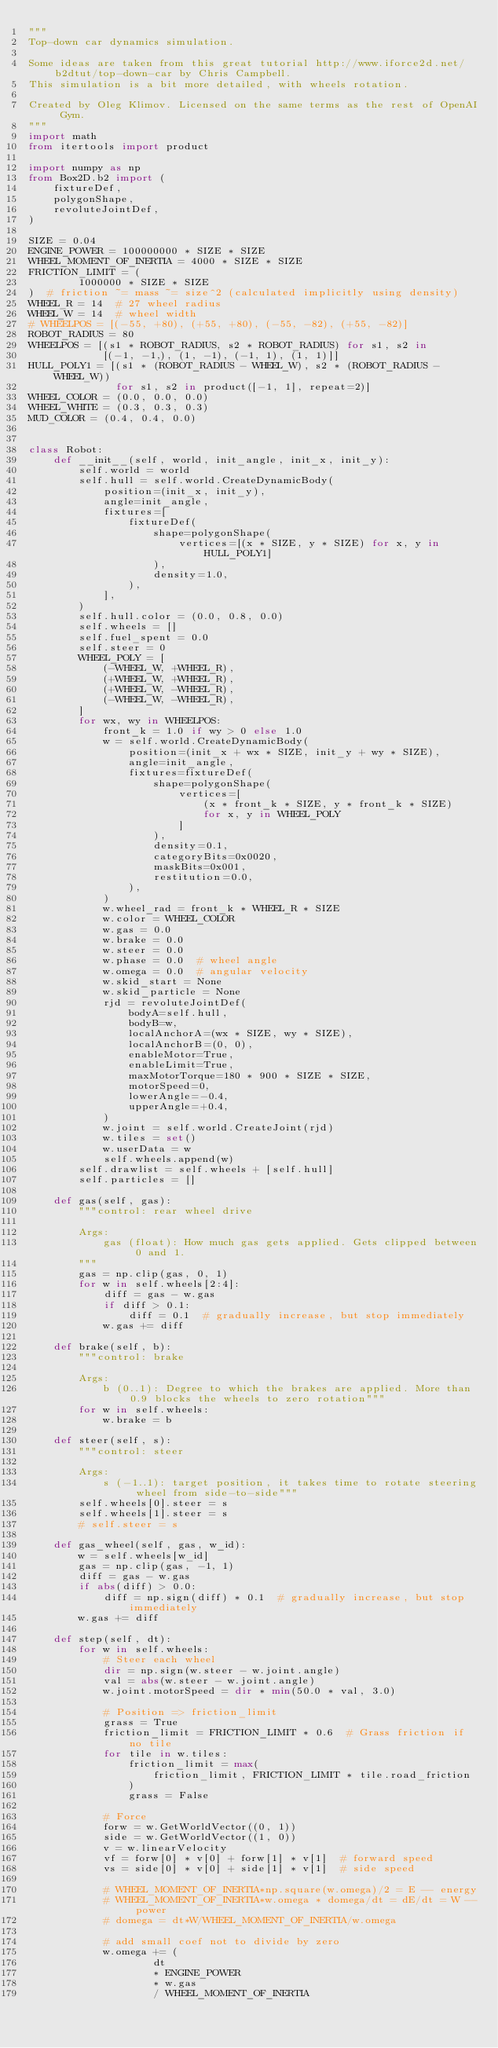<code> <loc_0><loc_0><loc_500><loc_500><_Python_>"""
Top-down car dynamics simulation.

Some ideas are taken from this great tutorial http://www.iforce2d.net/b2dtut/top-down-car by Chris Campbell.
This simulation is a bit more detailed, with wheels rotation.

Created by Oleg Klimov. Licensed on the same terms as the rest of OpenAI Gym.
"""
import math
from itertools import product

import numpy as np
from Box2D.b2 import (
    fixtureDef,
    polygonShape,
    revoluteJointDef,
)

SIZE = 0.04
ENGINE_POWER = 100000000 * SIZE * SIZE
WHEEL_MOMENT_OF_INERTIA = 4000 * SIZE * SIZE
FRICTION_LIMIT = (
        1000000 * SIZE * SIZE
)  # friction ~= mass ~= size^2 (calculated implicitly using density)
WHEEL_R = 14  # 27 wheel radius
WHEEL_W = 14  # wheel width
# WHEELPOS = [(-55, +80), (+55, +80), (-55, -82), (+55, -82)]
ROBOT_RADIUS = 80
WHEELPOS = [(s1 * ROBOT_RADIUS, s2 * ROBOT_RADIUS) for s1, s2 in
            [(-1, -1,), (1, -1), (-1, 1), (1, 1)]]
HULL_POLY1 = [(s1 * (ROBOT_RADIUS - WHEEL_W), s2 * (ROBOT_RADIUS - WHEEL_W))
              for s1, s2 in product([-1, 1], repeat=2)]
WHEEL_COLOR = (0.0, 0.0, 0.0)
WHEEL_WHITE = (0.3, 0.3, 0.3)
MUD_COLOR = (0.4, 0.4, 0.0)


class Robot:
    def __init__(self, world, init_angle, init_x, init_y):
        self.world = world
        self.hull = self.world.CreateDynamicBody(
            position=(init_x, init_y),
            angle=init_angle,
            fixtures=[
                fixtureDef(
                    shape=polygonShape(
                        vertices=[(x * SIZE, y * SIZE) for x, y in HULL_POLY1]
                    ),
                    density=1.0,
                ),
            ],
        )
        self.hull.color = (0.0, 0.8, 0.0)
        self.wheels = []
        self.fuel_spent = 0.0
        self.steer = 0
        WHEEL_POLY = [
            (-WHEEL_W, +WHEEL_R),
            (+WHEEL_W, +WHEEL_R),
            (+WHEEL_W, -WHEEL_R),
            (-WHEEL_W, -WHEEL_R),
        ]
        for wx, wy in WHEELPOS:
            front_k = 1.0 if wy > 0 else 1.0
            w = self.world.CreateDynamicBody(
                position=(init_x + wx * SIZE, init_y + wy * SIZE),
                angle=init_angle,
                fixtures=fixtureDef(
                    shape=polygonShape(
                        vertices=[
                            (x * front_k * SIZE, y * front_k * SIZE)
                            for x, y in WHEEL_POLY
                        ]
                    ),
                    density=0.1,
                    categoryBits=0x0020,
                    maskBits=0x001,
                    restitution=0.0,
                ),
            )
            w.wheel_rad = front_k * WHEEL_R * SIZE
            w.color = WHEEL_COLOR
            w.gas = 0.0
            w.brake = 0.0
            w.steer = 0.0
            w.phase = 0.0  # wheel angle
            w.omega = 0.0  # angular velocity
            w.skid_start = None
            w.skid_particle = None
            rjd = revoluteJointDef(
                bodyA=self.hull,
                bodyB=w,
                localAnchorA=(wx * SIZE, wy * SIZE),
                localAnchorB=(0, 0),
                enableMotor=True,
                enableLimit=True,
                maxMotorTorque=180 * 900 * SIZE * SIZE,
                motorSpeed=0,
                lowerAngle=-0.4,
                upperAngle=+0.4,
            )
            w.joint = self.world.CreateJoint(rjd)
            w.tiles = set()
            w.userData = w
            self.wheels.append(w)
        self.drawlist = self.wheels + [self.hull]
        self.particles = []

    def gas(self, gas):
        """control: rear wheel drive

        Args:
            gas (float): How much gas gets applied. Gets clipped between 0 and 1.
        """
        gas = np.clip(gas, 0, 1)
        for w in self.wheels[2:4]:
            diff = gas - w.gas
            if diff > 0.1:
                diff = 0.1  # gradually increase, but stop immediately
            w.gas += diff

    def brake(self, b):
        """control: brake

        Args:
            b (0..1): Degree to which the brakes are applied. More than 0.9 blocks the wheels to zero rotation"""
        for w in self.wheels:
            w.brake = b

    def steer(self, s):
        """control: steer

        Args:
            s (-1..1): target position, it takes time to rotate steering wheel from side-to-side"""
        self.wheels[0].steer = s
        self.wheels[1].steer = s
        # self.steer = s

    def gas_wheel(self, gas, w_id):
        w = self.wheels[w_id]
        gas = np.clip(gas, -1, 1)
        diff = gas - w.gas
        if abs(diff) > 0.0:
            diff = np.sign(diff) * 0.1  # gradually increase, but stop immediately
        w.gas += diff

    def step(self, dt):
        for w in self.wheels:
            # Steer each wheel
            dir = np.sign(w.steer - w.joint.angle)
            val = abs(w.steer - w.joint.angle)
            w.joint.motorSpeed = dir * min(50.0 * val, 3.0)

            # Position => friction_limit
            grass = True
            friction_limit = FRICTION_LIMIT * 0.6  # Grass friction if no tile
            for tile in w.tiles:
                friction_limit = max(
                    friction_limit, FRICTION_LIMIT * tile.road_friction
                )
                grass = False

            # Force
            forw = w.GetWorldVector((0, 1))
            side = w.GetWorldVector((1, 0))
            v = w.linearVelocity
            vf = forw[0] * v[0] + forw[1] * v[1]  # forward speed
            vs = side[0] * v[0] + side[1] * v[1]  # side speed

            # WHEEL_MOMENT_OF_INERTIA*np.square(w.omega)/2 = E -- energy
            # WHEEL_MOMENT_OF_INERTIA*w.omega * domega/dt = dE/dt = W -- power
            # domega = dt*W/WHEEL_MOMENT_OF_INERTIA/w.omega

            # add small coef not to divide by zero
            w.omega += (
                    dt
                    * ENGINE_POWER
                    * w.gas
                    / WHEEL_MOMENT_OF_INERTIA</code> 